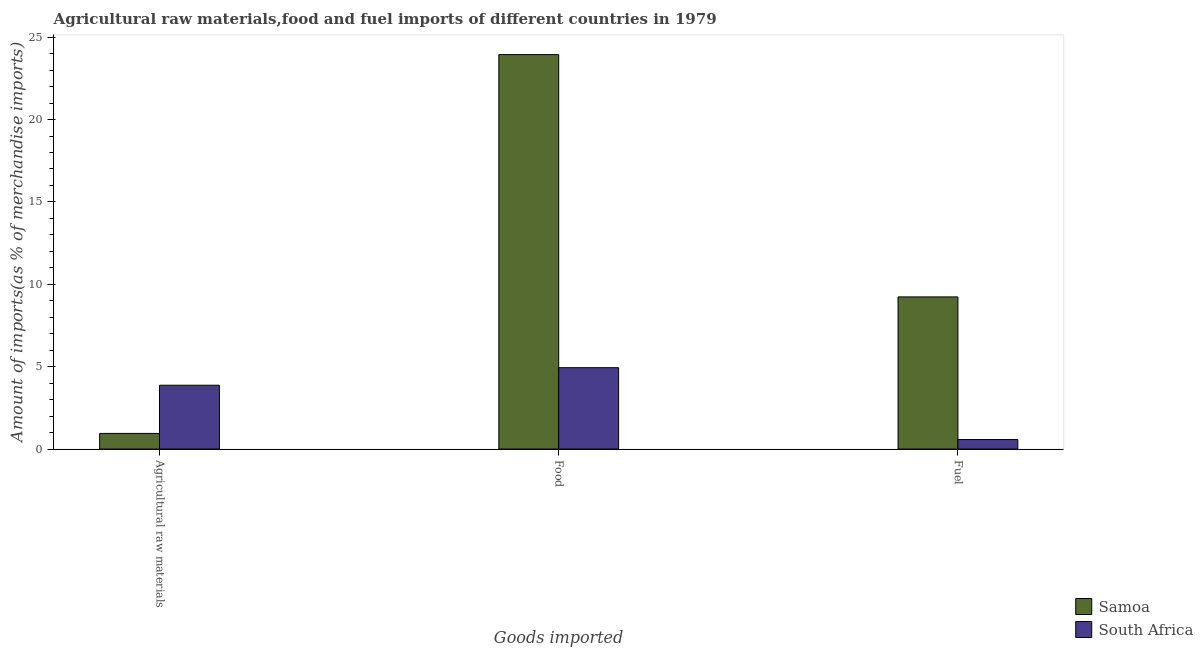How many different coloured bars are there?
Your answer should be very brief. 2. How many groups of bars are there?
Your answer should be very brief. 3. Are the number of bars per tick equal to the number of legend labels?
Provide a short and direct response. Yes. How many bars are there on the 2nd tick from the right?
Your response must be concise. 2. What is the label of the 1st group of bars from the left?
Keep it short and to the point. Agricultural raw materials. What is the percentage of fuel imports in Samoa?
Ensure brevity in your answer.  9.23. Across all countries, what is the maximum percentage of raw materials imports?
Ensure brevity in your answer.  3.88. Across all countries, what is the minimum percentage of food imports?
Make the answer very short. 4.94. In which country was the percentage of fuel imports maximum?
Your answer should be very brief. Samoa. In which country was the percentage of fuel imports minimum?
Your response must be concise. South Africa. What is the total percentage of fuel imports in the graph?
Ensure brevity in your answer.  9.81. What is the difference between the percentage of food imports in Samoa and that in South Africa?
Your answer should be very brief. 19. What is the difference between the percentage of raw materials imports in Samoa and the percentage of food imports in South Africa?
Ensure brevity in your answer.  -3.99. What is the average percentage of raw materials imports per country?
Your response must be concise. 2.41. What is the difference between the percentage of fuel imports and percentage of food imports in Samoa?
Make the answer very short. -14.71. What is the ratio of the percentage of raw materials imports in Samoa to that in South Africa?
Your answer should be compact. 0.25. Is the difference between the percentage of food imports in South Africa and Samoa greater than the difference between the percentage of raw materials imports in South Africa and Samoa?
Your response must be concise. No. What is the difference between the highest and the second highest percentage of fuel imports?
Ensure brevity in your answer.  8.66. What is the difference between the highest and the lowest percentage of food imports?
Give a very brief answer. 19. Is the sum of the percentage of fuel imports in South Africa and Samoa greater than the maximum percentage of food imports across all countries?
Provide a short and direct response. No. What does the 1st bar from the left in Agricultural raw materials represents?
Provide a short and direct response. Samoa. What does the 2nd bar from the right in Agricultural raw materials represents?
Keep it short and to the point. Samoa. Is it the case that in every country, the sum of the percentage of raw materials imports and percentage of food imports is greater than the percentage of fuel imports?
Give a very brief answer. Yes. How many bars are there?
Keep it short and to the point. 6. Are all the bars in the graph horizontal?
Your answer should be very brief. No. What is the difference between two consecutive major ticks on the Y-axis?
Your answer should be very brief. 5. Does the graph contain any zero values?
Give a very brief answer. No. Where does the legend appear in the graph?
Keep it short and to the point. Bottom right. What is the title of the graph?
Your answer should be very brief. Agricultural raw materials,food and fuel imports of different countries in 1979. Does "Norway" appear as one of the legend labels in the graph?
Your answer should be compact. No. What is the label or title of the X-axis?
Give a very brief answer. Goods imported. What is the label or title of the Y-axis?
Your answer should be very brief. Amount of imports(as % of merchandise imports). What is the Amount of imports(as % of merchandise imports) in Samoa in Agricultural raw materials?
Give a very brief answer. 0.95. What is the Amount of imports(as % of merchandise imports) of South Africa in Agricultural raw materials?
Give a very brief answer. 3.88. What is the Amount of imports(as % of merchandise imports) of Samoa in Food?
Make the answer very short. 23.94. What is the Amount of imports(as % of merchandise imports) of South Africa in Food?
Your response must be concise. 4.94. What is the Amount of imports(as % of merchandise imports) in Samoa in Fuel?
Your answer should be compact. 9.23. What is the Amount of imports(as % of merchandise imports) in South Africa in Fuel?
Provide a short and direct response. 0.58. Across all Goods imported, what is the maximum Amount of imports(as % of merchandise imports) in Samoa?
Provide a succinct answer. 23.94. Across all Goods imported, what is the maximum Amount of imports(as % of merchandise imports) of South Africa?
Provide a short and direct response. 4.94. Across all Goods imported, what is the minimum Amount of imports(as % of merchandise imports) of Samoa?
Provide a short and direct response. 0.95. Across all Goods imported, what is the minimum Amount of imports(as % of merchandise imports) in South Africa?
Make the answer very short. 0.58. What is the total Amount of imports(as % of merchandise imports) in Samoa in the graph?
Keep it short and to the point. 34.12. What is the total Amount of imports(as % of merchandise imports) in South Africa in the graph?
Provide a short and direct response. 9.39. What is the difference between the Amount of imports(as % of merchandise imports) of Samoa in Agricultural raw materials and that in Food?
Your answer should be compact. -22.99. What is the difference between the Amount of imports(as % of merchandise imports) of South Africa in Agricultural raw materials and that in Food?
Keep it short and to the point. -1.06. What is the difference between the Amount of imports(as % of merchandise imports) of Samoa in Agricultural raw materials and that in Fuel?
Make the answer very short. -8.28. What is the difference between the Amount of imports(as % of merchandise imports) in South Africa in Agricultural raw materials and that in Fuel?
Your answer should be very brief. 3.3. What is the difference between the Amount of imports(as % of merchandise imports) in Samoa in Food and that in Fuel?
Your answer should be very brief. 14.71. What is the difference between the Amount of imports(as % of merchandise imports) of South Africa in Food and that in Fuel?
Your response must be concise. 4.36. What is the difference between the Amount of imports(as % of merchandise imports) of Samoa in Agricultural raw materials and the Amount of imports(as % of merchandise imports) of South Africa in Food?
Offer a terse response. -3.99. What is the difference between the Amount of imports(as % of merchandise imports) of Samoa in Agricultural raw materials and the Amount of imports(as % of merchandise imports) of South Africa in Fuel?
Make the answer very short. 0.37. What is the difference between the Amount of imports(as % of merchandise imports) of Samoa in Food and the Amount of imports(as % of merchandise imports) of South Africa in Fuel?
Keep it short and to the point. 23.36. What is the average Amount of imports(as % of merchandise imports) of Samoa per Goods imported?
Offer a terse response. 11.37. What is the average Amount of imports(as % of merchandise imports) of South Africa per Goods imported?
Your answer should be compact. 3.13. What is the difference between the Amount of imports(as % of merchandise imports) in Samoa and Amount of imports(as % of merchandise imports) in South Africa in Agricultural raw materials?
Keep it short and to the point. -2.92. What is the difference between the Amount of imports(as % of merchandise imports) of Samoa and Amount of imports(as % of merchandise imports) of South Africa in Food?
Make the answer very short. 19. What is the difference between the Amount of imports(as % of merchandise imports) in Samoa and Amount of imports(as % of merchandise imports) in South Africa in Fuel?
Give a very brief answer. 8.66. What is the ratio of the Amount of imports(as % of merchandise imports) in Samoa in Agricultural raw materials to that in Food?
Keep it short and to the point. 0.04. What is the ratio of the Amount of imports(as % of merchandise imports) of South Africa in Agricultural raw materials to that in Food?
Offer a very short reply. 0.78. What is the ratio of the Amount of imports(as % of merchandise imports) in Samoa in Agricultural raw materials to that in Fuel?
Ensure brevity in your answer.  0.1. What is the ratio of the Amount of imports(as % of merchandise imports) in South Africa in Agricultural raw materials to that in Fuel?
Your answer should be very brief. 6.71. What is the ratio of the Amount of imports(as % of merchandise imports) of Samoa in Food to that in Fuel?
Keep it short and to the point. 2.59. What is the ratio of the Amount of imports(as % of merchandise imports) of South Africa in Food to that in Fuel?
Your answer should be very brief. 8.55. What is the difference between the highest and the second highest Amount of imports(as % of merchandise imports) in Samoa?
Give a very brief answer. 14.71. What is the difference between the highest and the second highest Amount of imports(as % of merchandise imports) in South Africa?
Give a very brief answer. 1.06. What is the difference between the highest and the lowest Amount of imports(as % of merchandise imports) in Samoa?
Keep it short and to the point. 22.99. What is the difference between the highest and the lowest Amount of imports(as % of merchandise imports) of South Africa?
Provide a succinct answer. 4.36. 